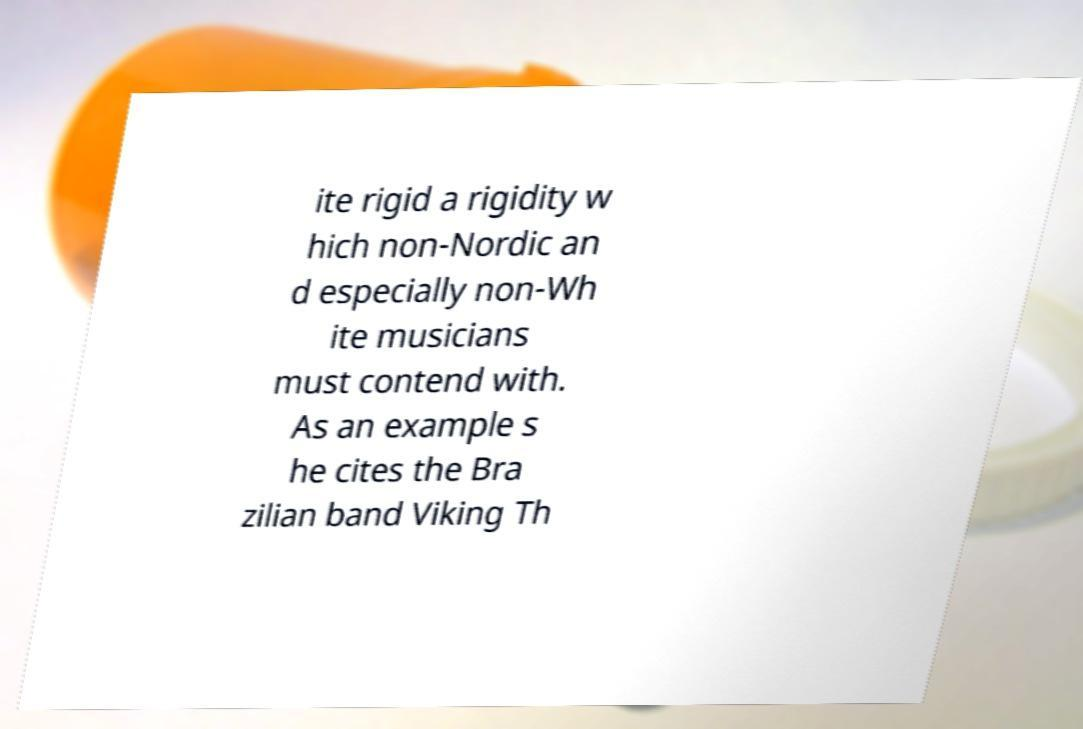What messages or text are displayed in this image? I need them in a readable, typed format. ite rigid a rigidity w hich non-Nordic an d especially non-Wh ite musicians must contend with. As an example s he cites the Bra zilian band Viking Th 